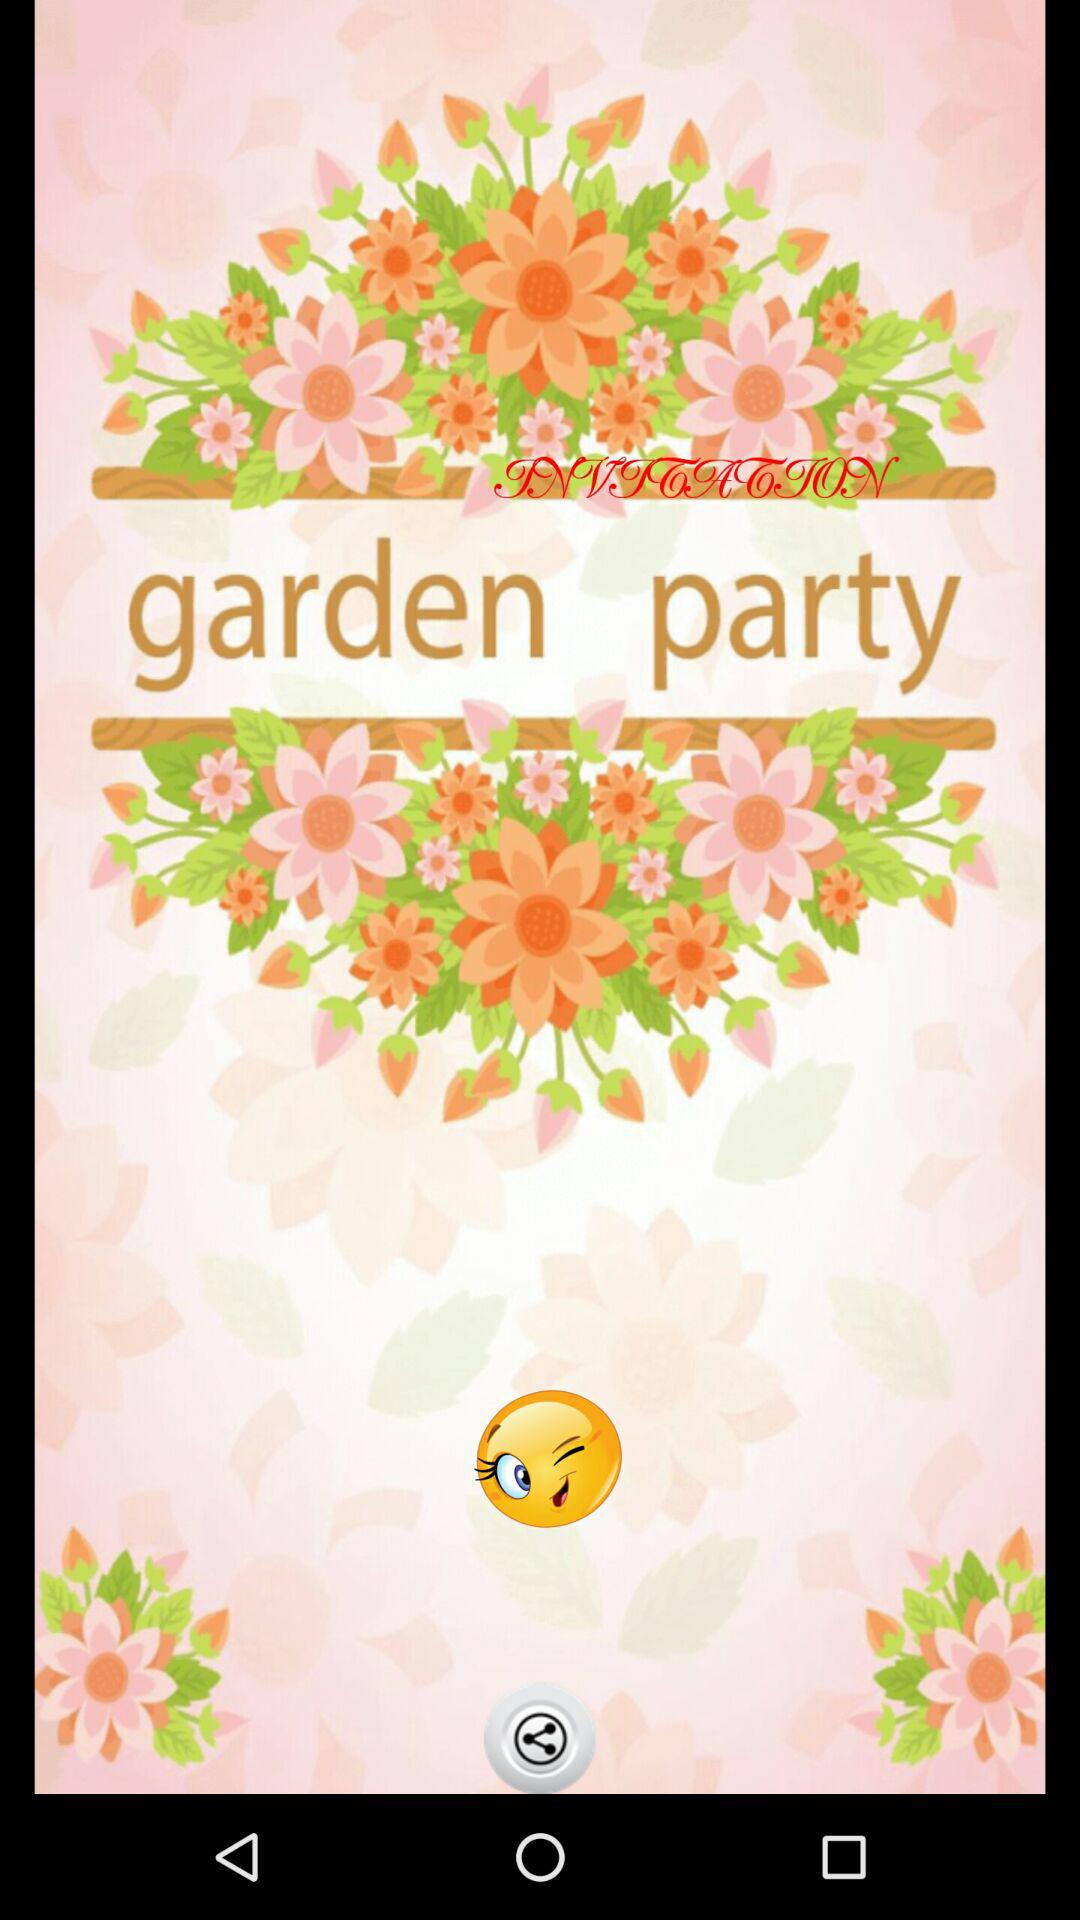What is the application name? The application name is "garden party". 